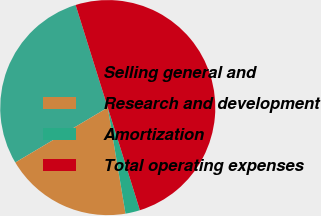Convert chart to OTSL. <chart><loc_0><loc_0><loc_500><loc_500><pie_chart><fcel>Selling general and<fcel>Research and development<fcel>Amortization<fcel>Total operating expenses<nl><fcel>28.7%<fcel>19.11%<fcel>2.19%<fcel>50.0%<nl></chart> 